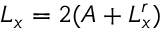<formula> <loc_0><loc_0><loc_500><loc_500>L _ { x } = 2 ( A + L _ { x } ^ { r } )</formula> 